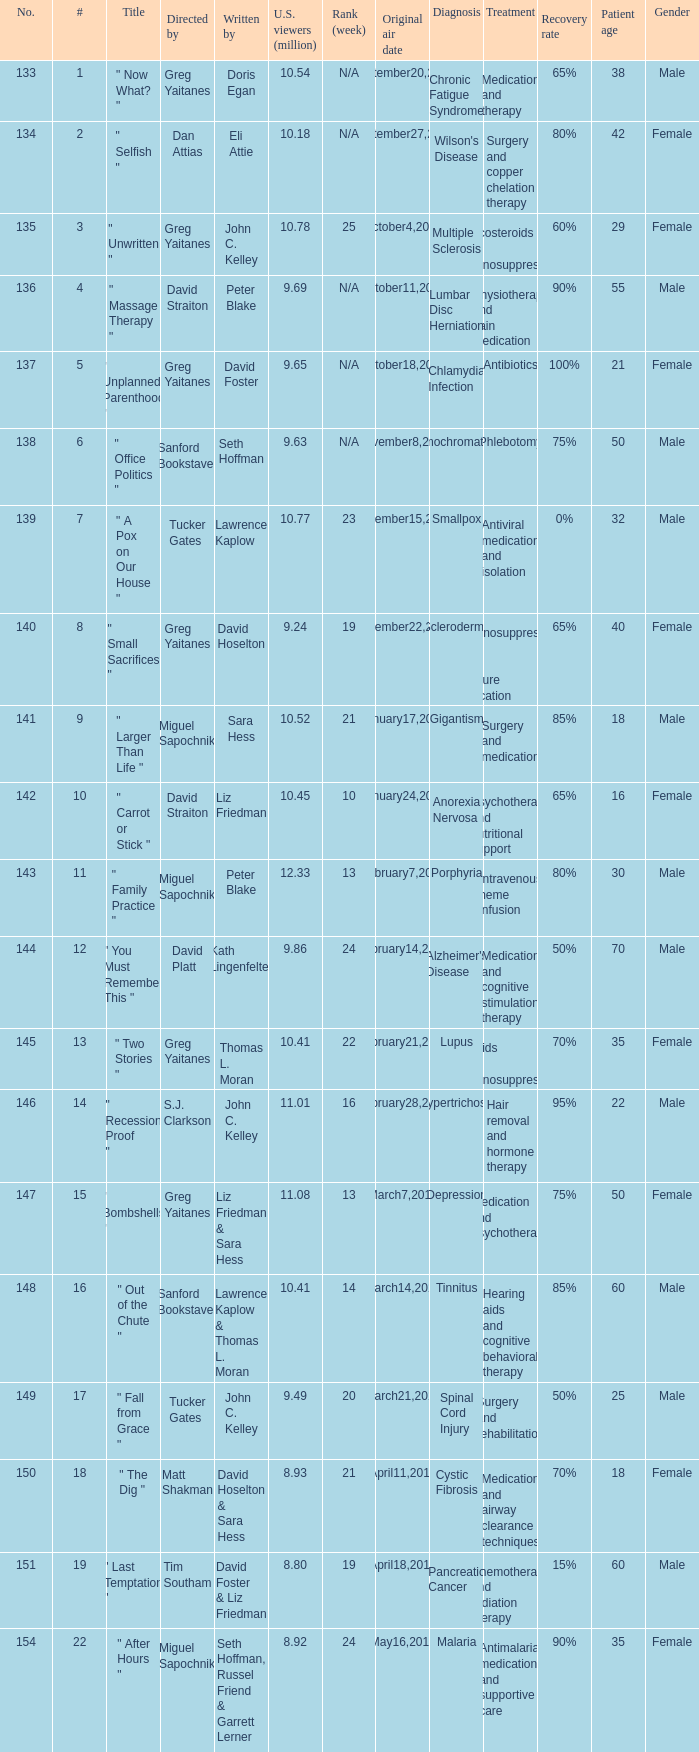Where did the episode rank that was written by thomas l. moran? 22.0. 